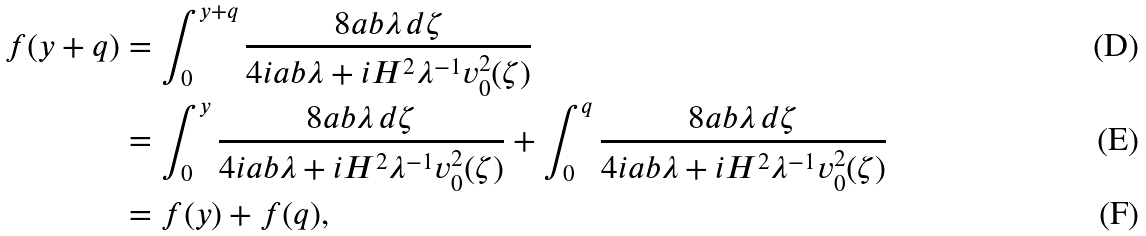<formula> <loc_0><loc_0><loc_500><loc_500>f ( y + q ) & = \int _ { 0 } ^ { y + q } \frac { 8 a b \lambda \, d \zeta } { 4 i a b \lambda + i H ^ { 2 } \lambda ^ { - 1 } v _ { 0 } ^ { 2 } ( \zeta ) } \\ & = \int _ { 0 } ^ { y } \frac { 8 a b \lambda \, d \zeta } { 4 i a b \lambda + i H ^ { 2 } \lambda ^ { - 1 } v _ { 0 } ^ { 2 } ( \zeta ) } + \int _ { 0 } ^ { q } \frac { 8 a b \lambda \, d \zeta } { 4 i a b \lambda + i H ^ { 2 } \lambda ^ { - 1 } v _ { 0 } ^ { 2 } ( \zeta ) } \\ & = f ( y ) + f ( q ) ,</formula> 